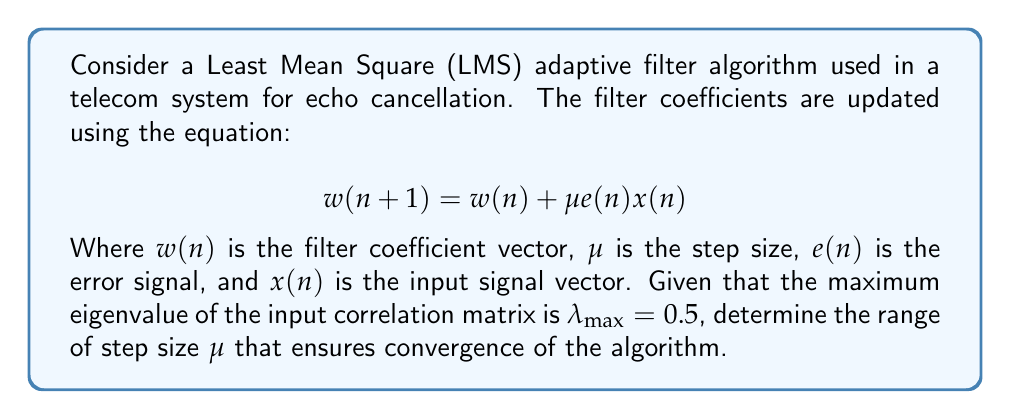What is the answer to this math problem? To analyze the convergence of the LMS algorithm, we follow these steps:

1) The convergence of the LMS algorithm depends on the step size $\mu$. For stability and convergence, $\mu$ must satisfy the condition:

   $$0 < \mu < \frac{2}{\lambda_{max}}$$

   Where $\lambda_{max}$ is the maximum eigenvalue of the input correlation matrix.

2) We are given that $\lambda_{max} = 0.5$. Let's substitute this into the inequality:

   $$0 < \mu < \frac{2}{0.5}$$

3) Simplify the right side of the inequality:

   $$0 < \mu < 4$$

4) Therefore, for the LMS algorithm to converge, the step size $\mu$ must be chosen from the open interval (0, 4).

This range ensures that the algorithm will converge to the optimal solution over time, without oscillating or diverging. A smaller $\mu$ within this range will result in slower but more stable convergence, while a larger $\mu$ will lead to faster convergence but may be less stable.
Answer: $0 < \mu < 4$ 